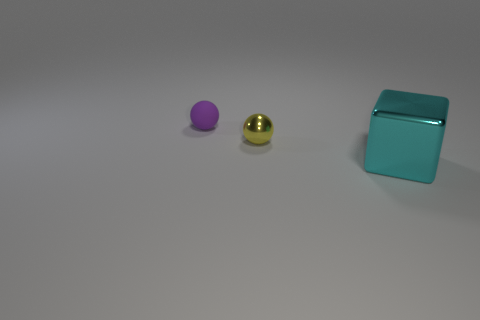There is a yellow shiny object that is the same shape as the purple matte thing; what is its size?
Provide a short and direct response. Small. What number of things are either small metal balls to the right of the purple matte ball or spheres that are in front of the purple thing?
Offer a terse response. 1. There is a object that is both on the right side of the small purple rubber object and on the left side of the large metallic block; what is its size?
Keep it short and to the point. Small. Do the purple rubber thing and the small thing that is in front of the purple matte ball have the same shape?
Offer a terse response. Yes. How many things are spheres that are on the right side of the small matte thing or purple metal things?
Your answer should be compact. 1. Are the cube and the tiny object that is right of the purple thing made of the same material?
Offer a very short reply. Yes. What is the shape of the object that is on the right side of the metal thing that is left of the big metallic object?
Provide a succinct answer. Cube. Are there any other things that are made of the same material as the large cube?
Provide a short and direct response. Yes. What is the shape of the big metal object?
Provide a short and direct response. Cube. How big is the object that is on the left side of the small sphere in front of the purple ball?
Make the answer very short. Small. 